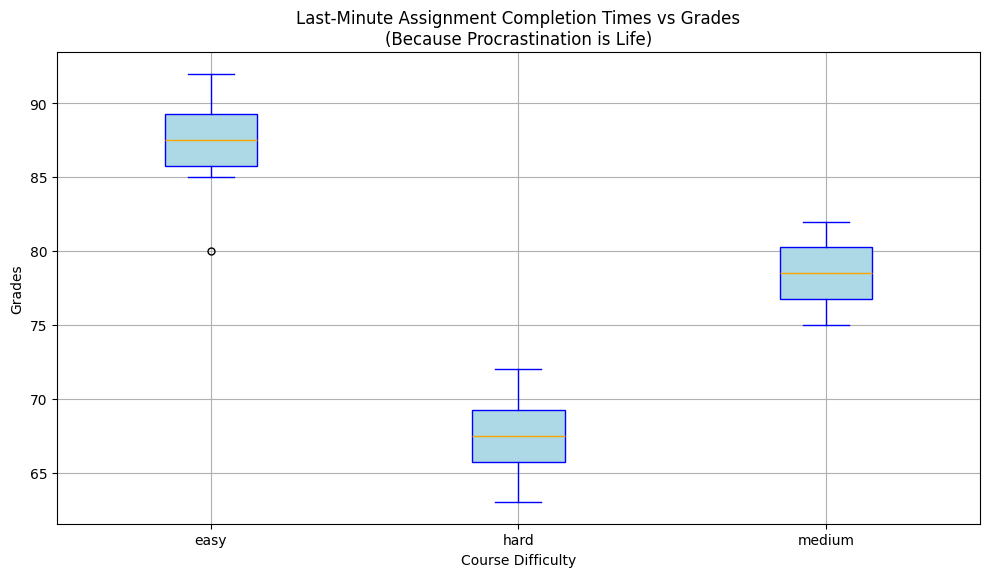What course difficulty has the highest median grade? The box plot shows the median value for each course difficulty as a line inside the box. The tallest line belongs to the "easy" category, indicating it has the highest median grade.
Answer: easy Which course difficulty has the greatest range in grades? The range is the difference between the maximum and minimum values shown by the whiskers. The "hard" category shows a taller range of whiskers compared to "easy" and "medium," indicating it has the greatest range.
Answer: hard Does the median grade decrease as course difficulty increases? By comparing the medians (lines inside the boxes) across course difficulties, you can see the medians are highest for "easy," then lower for "medium," and lowest for "hard."
Answer: yes Which group shows the most outliers in grades? Outliers are marked by red dots outside the whiskers. Count the red dots for each category; "medium" course difficulty has the most red dots.
Answer: medium How does the median grade for "medium" difficulty compare to that for "hard" difficulty? Check the lines in the boxes. The median for "medium" is higher than that for "hard," indicating that students generally scored better in "medium" difficulty.
Answer: "medium" is higher Are the median grades for "easy" courses closer to 90 or 80? Look at the line inside the box for "easy" courses. The median appears closer to 90 than 80.
Answer: 90 In which course difficulty are the grades most tightly clustered? Look at the height of the boxes. The "easy" category has the shortest box height, indicating the most tightly clustered grades.
Answer: easy 